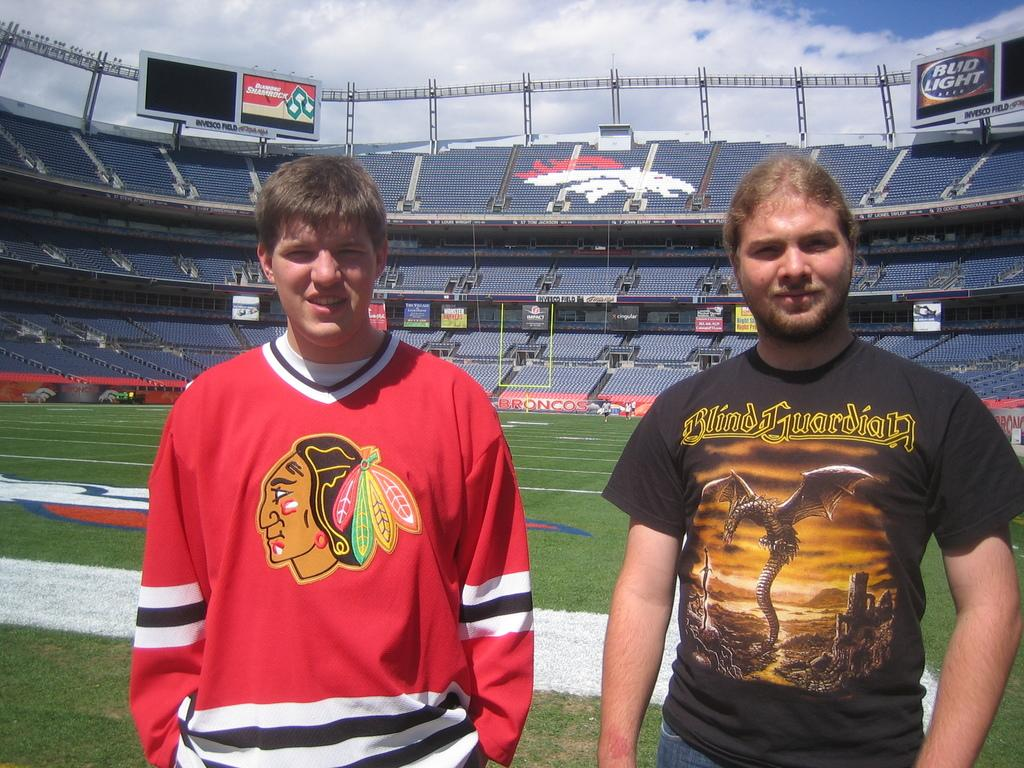<image>
Present a compact description of the photo's key features. a man standing next to another one with a shirt that has the word Guardian on it 